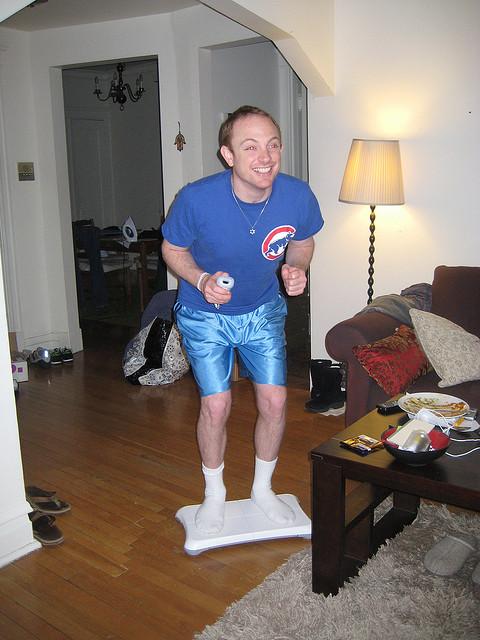What is this person standing on?
Quick response, please. Wii balance board. What kind of shoes are lying around the room?
Give a very brief answer. Flip flops. What video game system is this man using?
Be succinct. Wii. 